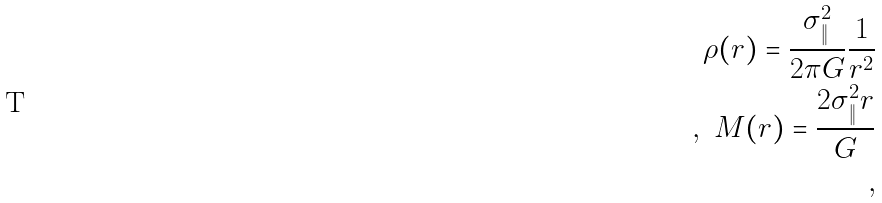Convert formula to latex. <formula><loc_0><loc_0><loc_500><loc_500>\rho ( r ) = \frac { \sigma _ { \| } ^ { 2 } } { 2 \pi G } \frac { 1 } { r ^ { 2 } } \\ , \ M ( r ) = \frac { 2 \sigma _ { \| } ^ { 2 } r } { G } \\ ,</formula> 